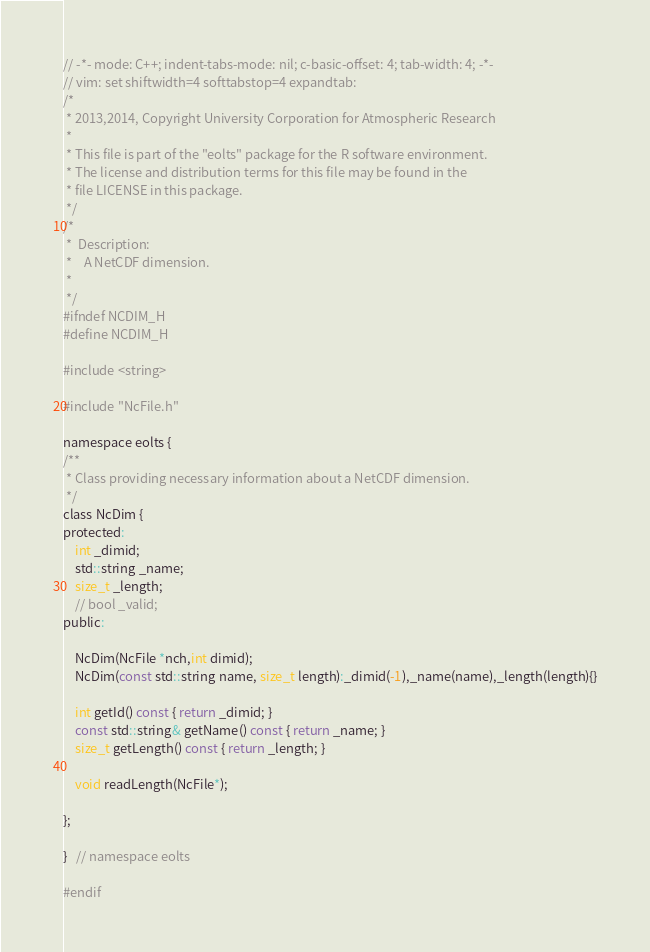<code> <loc_0><loc_0><loc_500><loc_500><_C_>// -*- mode: C++; indent-tabs-mode: nil; c-basic-offset: 4; tab-width: 4; -*-
// vim: set shiftwidth=4 softtabstop=4 expandtab:
/*
 * 2013,2014, Copyright University Corporation for Atmospheric Research
 * 
 * This file is part of the "eolts" package for the R software environment.
 * The license and distribution terms for this file may be found in the
 * file LICENSE in this package.
 */
/*
 *  Description:
 *    A NetCDF dimension.
 * 
 */
#ifndef NCDIM_H
#define NCDIM_H

#include <string>

#include "NcFile.h"

namespace eolts {
/**
 * Class providing necessary information about a NetCDF dimension.
 */
class NcDim {
protected:
    int _dimid;
    std::string _name;
    size_t _length;
    // bool _valid;
public:

    NcDim(NcFile *nch,int dimid);
    NcDim(const std::string name, size_t length):_dimid(-1),_name(name),_length(length){}

    int getId() const { return _dimid; }
    const std::string& getName() const { return _name; }
    size_t getLength() const { return _length; }

    void readLength(NcFile*);

};

}   // namespace eolts

#endif
</code> 